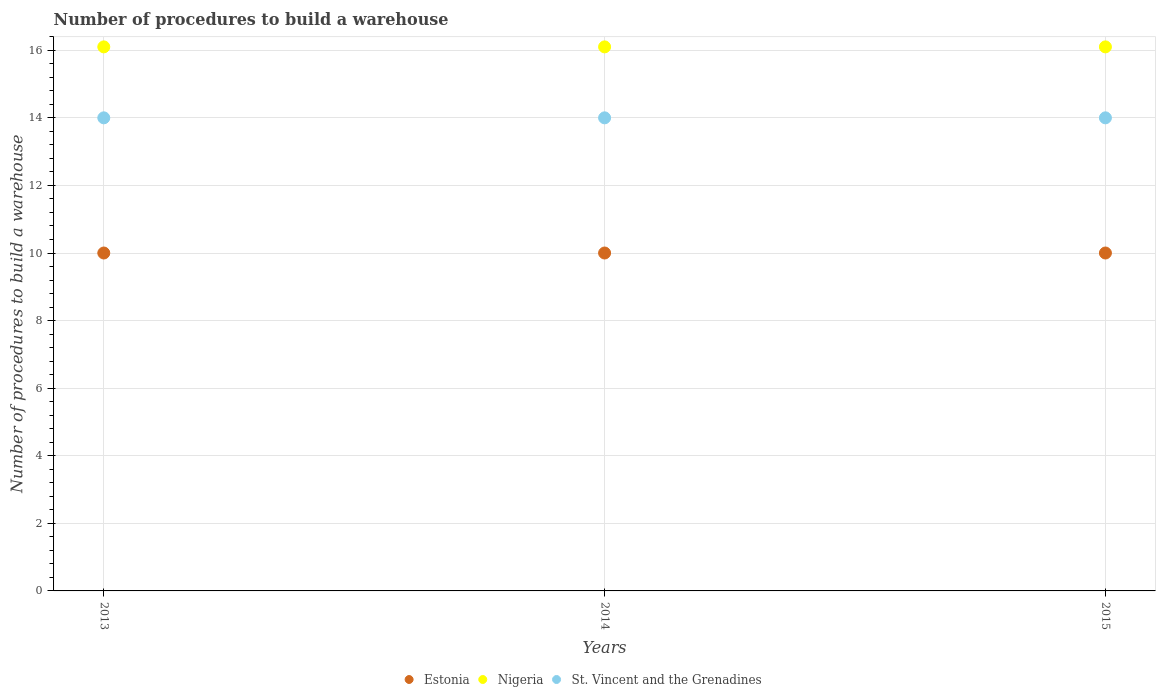How many different coloured dotlines are there?
Your answer should be very brief. 3. Is the number of dotlines equal to the number of legend labels?
Provide a short and direct response. Yes. What is the number of procedures to build a warehouse in in Nigeria in 2013?
Your answer should be very brief. 16.1. Across all years, what is the maximum number of procedures to build a warehouse in in Nigeria?
Your answer should be very brief. 16.1. Across all years, what is the minimum number of procedures to build a warehouse in in Estonia?
Provide a succinct answer. 10. In which year was the number of procedures to build a warehouse in in St. Vincent and the Grenadines minimum?
Offer a terse response. 2013. What is the total number of procedures to build a warehouse in in St. Vincent and the Grenadines in the graph?
Give a very brief answer. 42. What is the difference between the number of procedures to build a warehouse in in Nigeria in 2013 and that in 2015?
Your answer should be very brief. 0. What is the difference between the number of procedures to build a warehouse in in St. Vincent and the Grenadines in 2015 and the number of procedures to build a warehouse in in Estonia in 2014?
Ensure brevity in your answer.  4. In the year 2013, what is the difference between the number of procedures to build a warehouse in in St. Vincent and the Grenadines and number of procedures to build a warehouse in in Nigeria?
Give a very brief answer. -2.1. In how many years, is the number of procedures to build a warehouse in in St. Vincent and the Grenadines greater than 0.4?
Offer a very short reply. 3. Is the difference between the number of procedures to build a warehouse in in St. Vincent and the Grenadines in 2014 and 2015 greater than the difference between the number of procedures to build a warehouse in in Nigeria in 2014 and 2015?
Provide a short and direct response. No. What is the difference between the highest and the lowest number of procedures to build a warehouse in in St. Vincent and the Grenadines?
Offer a terse response. 0. In how many years, is the number of procedures to build a warehouse in in Nigeria greater than the average number of procedures to build a warehouse in in Nigeria taken over all years?
Your answer should be compact. 0. Is the sum of the number of procedures to build a warehouse in in Nigeria in 2014 and 2015 greater than the maximum number of procedures to build a warehouse in in St. Vincent and the Grenadines across all years?
Your response must be concise. Yes. Does the number of procedures to build a warehouse in in Estonia monotonically increase over the years?
Provide a succinct answer. No. How many dotlines are there?
Provide a succinct answer. 3. How many years are there in the graph?
Give a very brief answer. 3. What is the difference between two consecutive major ticks on the Y-axis?
Ensure brevity in your answer.  2. Does the graph contain any zero values?
Provide a short and direct response. No. Does the graph contain grids?
Keep it short and to the point. Yes. How are the legend labels stacked?
Your response must be concise. Horizontal. What is the title of the graph?
Provide a short and direct response. Number of procedures to build a warehouse. Does "Bahamas" appear as one of the legend labels in the graph?
Provide a short and direct response. No. What is the label or title of the Y-axis?
Offer a terse response. Number of procedures to build a warehouse. What is the Number of procedures to build a warehouse in Estonia in 2013?
Provide a succinct answer. 10. What is the Number of procedures to build a warehouse in Nigeria in 2013?
Make the answer very short. 16.1. What is the Number of procedures to build a warehouse in Nigeria in 2014?
Offer a very short reply. 16.1. Across all years, what is the maximum Number of procedures to build a warehouse of Nigeria?
Ensure brevity in your answer.  16.1. Across all years, what is the maximum Number of procedures to build a warehouse of St. Vincent and the Grenadines?
Your answer should be very brief. 14. Across all years, what is the minimum Number of procedures to build a warehouse of Nigeria?
Your answer should be very brief. 16.1. Across all years, what is the minimum Number of procedures to build a warehouse in St. Vincent and the Grenadines?
Provide a short and direct response. 14. What is the total Number of procedures to build a warehouse of Estonia in the graph?
Keep it short and to the point. 30. What is the total Number of procedures to build a warehouse of Nigeria in the graph?
Provide a succinct answer. 48.3. What is the total Number of procedures to build a warehouse in St. Vincent and the Grenadines in the graph?
Your answer should be very brief. 42. What is the difference between the Number of procedures to build a warehouse of Nigeria in 2013 and that in 2014?
Offer a terse response. 0. What is the difference between the Number of procedures to build a warehouse of St. Vincent and the Grenadines in 2013 and that in 2015?
Your answer should be very brief. 0. What is the difference between the Number of procedures to build a warehouse of Estonia in 2014 and that in 2015?
Provide a short and direct response. 0. What is the difference between the Number of procedures to build a warehouse of Nigeria in 2014 and that in 2015?
Ensure brevity in your answer.  0. What is the difference between the Number of procedures to build a warehouse of St. Vincent and the Grenadines in 2014 and that in 2015?
Your response must be concise. 0. What is the difference between the Number of procedures to build a warehouse of Estonia in 2013 and the Number of procedures to build a warehouse of Nigeria in 2014?
Offer a very short reply. -6.1. What is the difference between the Number of procedures to build a warehouse of Nigeria in 2013 and the Number of procedures to build a warehouse of St. Vincent and the Grenadines in 2014?
Keep it short and to the point. 2.1. What is the difference between the Number of procedures to build a warehouse in Estonia in 2013 and the Number of procedures to build a warehouse in Nigeria in 2015?
Give a very brief answer. -6.1. What is the difference between the Number of procedures to build a warehouse of Estonia in 2014 and the Number of procedures to build a warehouse of Nigeria in 2015?
Provide a succinct answer. -6.1. What is the difference between the Number of procedures to build a warehouse in Nigeria in 2014 and the Number of procedures to build a warehouse in St. Vincent and the Grenadines in 2015?
Make the answer very short. 2.1. What is the average Number of procedures to build a warehouse in Nigeria per year?
Your answer should be compact. 16.1. In the year 2013, what is the difference between the Number of procedures to build a warehouse of Estonia and Number of procedures to build a warehouse of Nigeria?
Make the answer very short. -6.1. In the year 2013, what is the difference between the Number of procedures to build a warehouse of Estonia and Number of procedures to build a warehouse of St. Vincent and the Grenadines?
Provide a succinct answer. -4. In the year 2013, what is the difference between the Number of procedures to build a warehouse of Nigeria and Number of procedures to build a warehouse of St. Vincent and the Grenadines?
Your response must be concise. 2.1. In the year 2014, what is the difference between the Number of procedures to build a warehouse of Estonia and Number of procedures to build a warehouse of Nigeria?
Offer a terse response. -6.1. In the year 2014, what is the difference between the Number of procedures to build a warehouse in Estonia and Number of procedures to build a warehouse in St. Vincent and the Grenadines?
Give a very brief answer. -4. In the year 2015, what is the difference between the Number of procedures to build a warehouse of Estonia and Number of procedures to build a warehouse of St. Vincent and the Grenadines?
Make the answer very short. -4. What is the ratio of the Number of procedures to build a warehouse of Estonia in 2013 to that in 2014?
Offer a very short reply. 1. What is the ratio of the Number of procedures to build a warehouse of Nigeria in 2013 to that in 2014?
Offer a very short reply. 1. What is the ratio of the Number of procedures to build a warehouse in Estonia in 2014 to that in 2015?
Your response must be concise. 1. What is the ratio of the Number of procedures to build a warehouse in Nigeria in 2014 to that in 2015?
Your answer should be very brief. 1. What is the difference between the highest and the second highest Number of procedures to build a warehouse of St. Vincent and the Grenadines?
Give a very brief answer. 0. What is the difference between the highest and the lowest Number of procedures to build a warehouse in Estonia?
Provide a short and direct response. 0. 